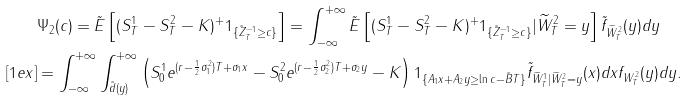<formula> <loc_0><loc_0><loc_500><loc_500>& \Psi _ { 2 } ( c ) = \tilde { E } \left [ ( S ^ { 1 } _ { T } - S ^ { 2 } _ { T } - K ) ^ { + } 1 _ { \{ \tilde { Z } ^ { - 1 } _ { T } \geq c \} } \right ] = \int _ { - \infty } ^ { + \infty } \tilde { E } \left [ ( S ^ { 1 } _ { T } - S ^ { 2 } _ { T } - K ) ^ { + } 1 _ { \{ \tilde { Z } ^ { - 1 } _ { T } \geq c \} } | \widetilde { W } ^ { 2 } _ { T } = y \right ] \tilde { f } _ { \widetilde { W } ^ { 2 } _ { T } } ( y ) d y \\ [ 1 e x ] & = \int _ { - \infty } ^ { + \infty } \int _ { \tilde { d } ( y ) } ^ { + \infty } \left ( S ^ { 1 } _ { 0 } e ^ { ( r - \frac { 1 } { 2 } \sigma _ { 1 } ^ { 2 } ) T + \sigma _ { 1 } x } - S ^ { 2 } _ { 0 } e ^ { ( r - \frac { 1 } { 2 } \sigma _ { 2 } ^ { 2 } ) T + \sigma _ { 2 } y } - K \right ) 1 _ { \{ A _ { 1 } x + A _ { 2 } y \geq \ln c - \tilde { B } T \} } \tilde { f } _ { \widetilde { W } ^ { 1 } _ { T } | \widetilde { W } ^ { 2 } _ { T } = y } ( x ) d x f _ { W ^ { 2 } _ { T } } ( y ) d y .</formula> 